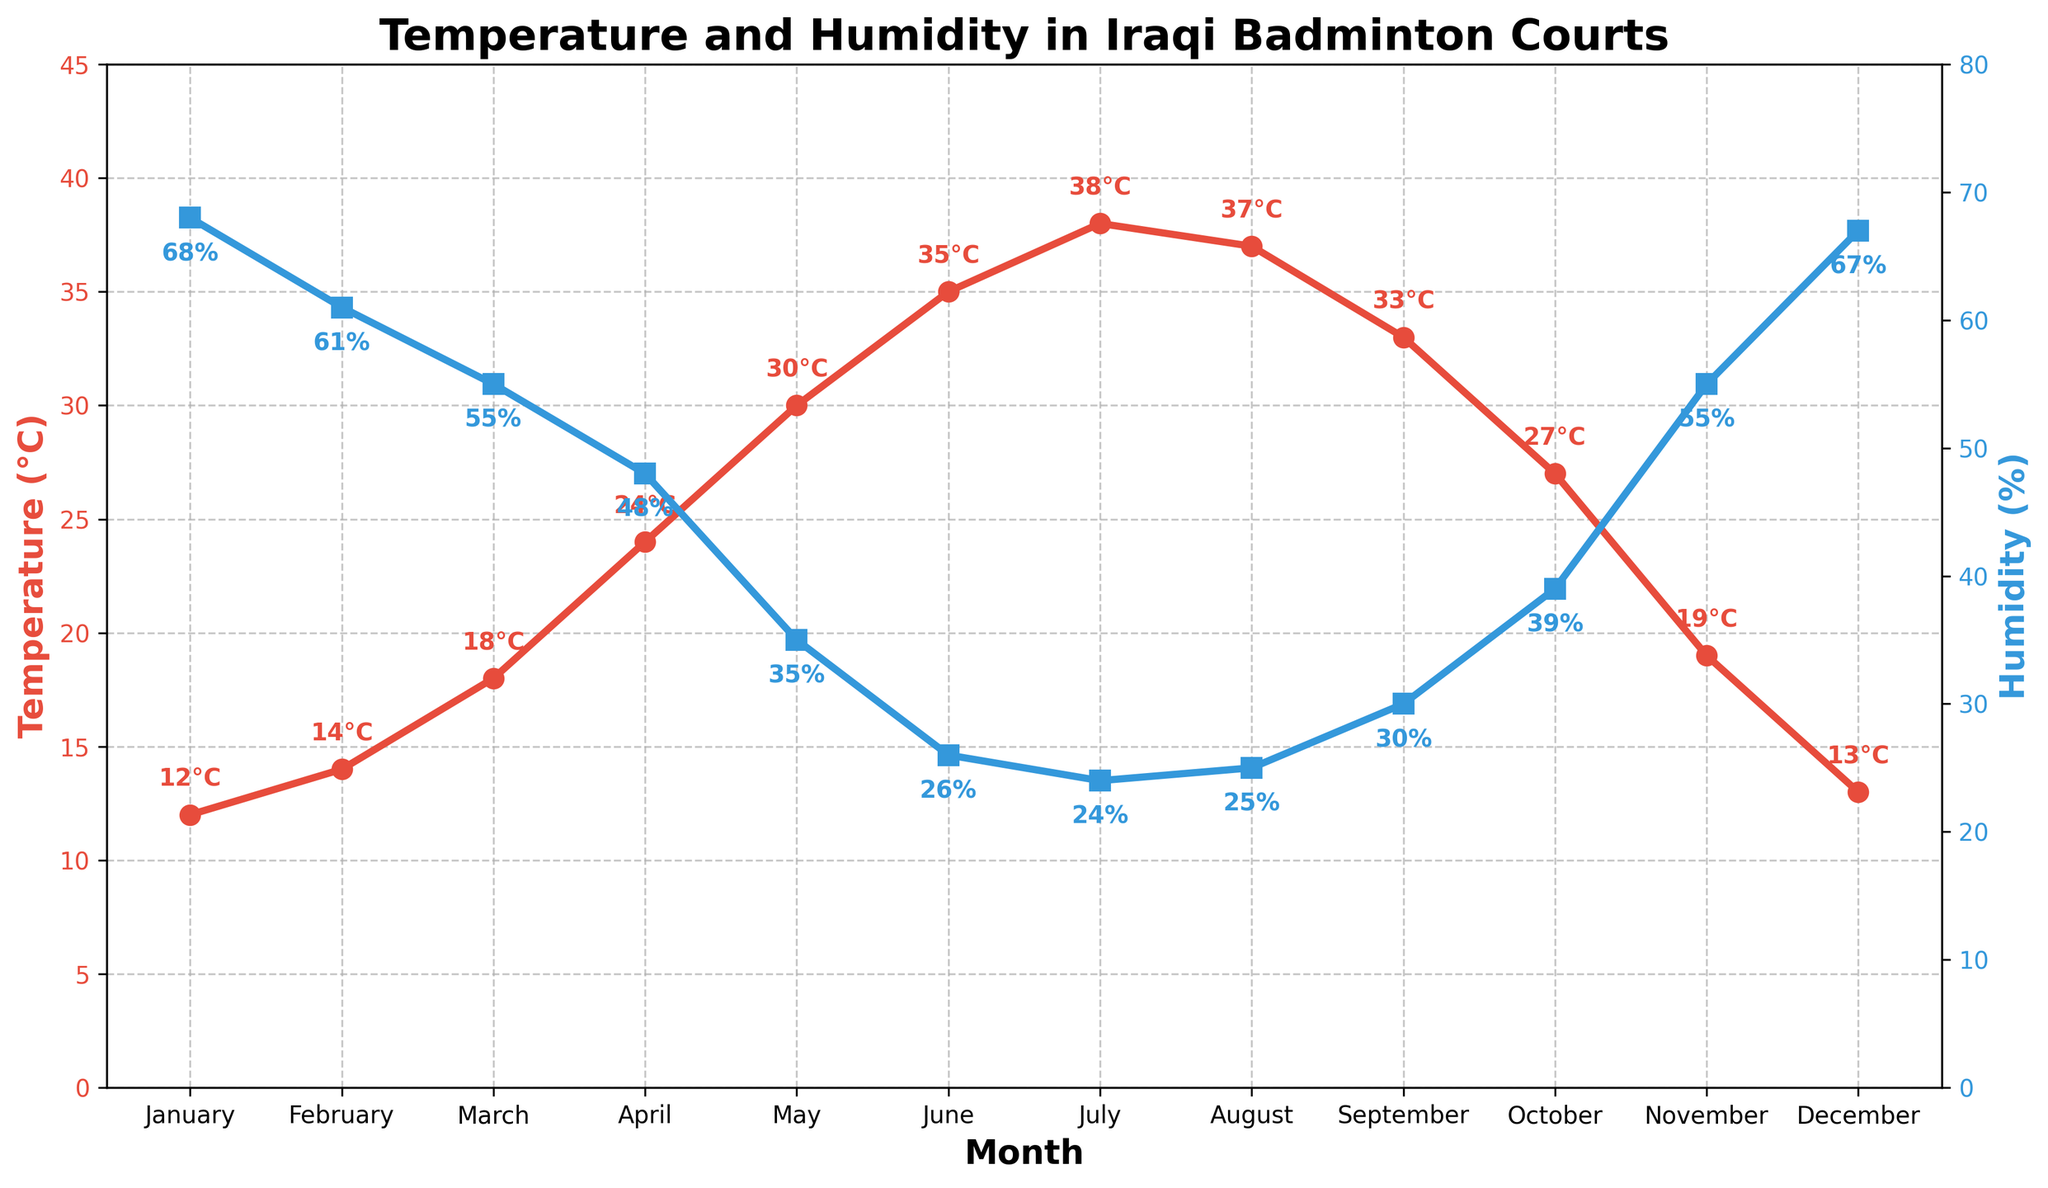What is the average temperature in April? April's temperature is explicitly shown as 24°C in the chart.
Answer: 24°C Which month has the lowest average temperature? By looking at the temperature line, the lowest point is in January where the temperature is 12°C.
Answer: January How does the average humidity in March compare to November? In March, the chart shows 55% humidity. In November, it also shows 55% humidity. Since they are equal, the humidity levels in March and November are the same.
Answer: The same Which month shows the largest difference between temperature and humidity? We calculate the difference between temperature and humidity for each month. The maximum difference is in July where the temperature is 38°C and humidity is 24%, making the difference 14 units.
Answer: July What is the general trend in temperature from January to July? The temperature line shows a steady increase from January (12°C) to July (38°C). Therefore, the general trend of temperature is increasing.
Answer: Increasing Which month experienced the highest spike in humidity after July? Examining the humidity line, the most significant increase post-July is found in October where humidity rises from 25% to 39%.
Answer: October What is the total sum of the average temperatures from June to August? Summing the temperatures of June (35°C), July (38°C), and August (37°C): 35 + 38 + 37 = 110°C.
Answer: 110°C In which month is the temperature closest to 30°C? The temperature line is at 30°C in May.
Answer: May Is there any month where the temperature is exactly twice the humidity? By checking each month: In April, the temperature is 24°C and humidity is 48%, so temperature is exactly half of humidity and not twice. Therefore, there isn't a month where this condition is met.
Answer: No What is the average humidity over the entire year? First, sum all the humidity values: 68+61+55+48+35+26+24+25+30+39+55+67 = 533. Then divide by the number of months: 533/12 = 44.42%.
Answer: 44.42% 